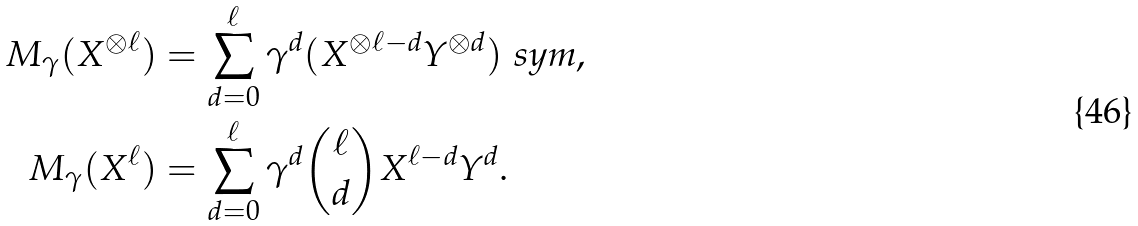<formula> <loc_0><loc_0><loc_500><loc_500>M _ { \gamma } ( X ^ { \otimes \ell } ) & = \sum _ { d = 0 } ^ { \ell } \gamma ^ { d } ( X ^ { \otimes \ell - d } Y ^ { \otimes d } ) _ { \ } s y m , \\ M _ { \gamma } ( X ^ { \ell } ) & = \sum _ { d = 0 } ^ { \ell } \gamma ^ { d } \binom { \ell } { d } X ^ { \ell - d } Y ^ { d } .</formula> 